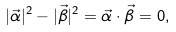Convert formula to latex. <formula><loc_0><loc_0><loc_500><loc_500>| \vec { \alpha } | ^ { 2 } - | \vec { \beta } | ^ { 2 } = \vec { \alpha } \cdot \vec { \beta } = 0 ,</formula> 